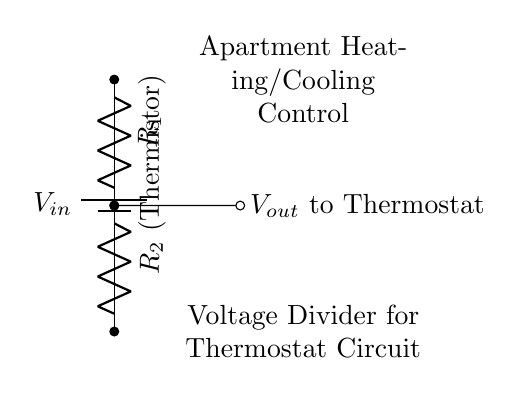What is the power supply voltage in this circuit? The circuit diagram shows a component labeled as "V_in," which represents the input voltage supplied to the circuit. However, the exact value is not indicated in this diagram. The user would need to refer to the specifications or additional documentation for the precise voltage.
Answer: V_in What components are present in the voltage divider? The circuit consists of a battery (V_in), a resistor labeled R_1, and a thermistor labeled R_2. These components are identified visually; the battery provides the input voltage, while the resistors function to create the voltage division necessary for the thermostat's operation.
Answer: Battery, R_1, R_2 What is the output voltage referred to in the circuit? The output voltage is labeled as "V_out" and is indicated to be the voltage across R_2 (the thermistor). This voltage is critical for the thermostat to sense temperature changes and regulate heating or cooling accordingly.
Answer: V_out Which component acts as a sensor in this circuit? The thermistor (R_2) serves as the sensor in the voltage divider circuit. Its resistance changes with temperature, influencing the output voltage (V_out) sent to the thermostat, thus I can adjust the heating and cooling systems based on temperature variations.
Answer: Thermistor How does the thermistor affect the output voltage? The thermistor's resistance changes with temperature, altering the voltage drop across it and thus affecting V_out. If the temperature increases, the resistance of the thermistor typically decreases, raising V_out. Conversely, if the temperature decreases, the resistance rises, causing V_out to drop. This relationship enables the thermostat to control the heating and cooling operations effectively.
Answer: Changes V_out What is the purpose of the voltage divider in this circuit? The voltage divider adjusts the input voltage to a lower output voltage suitable for the thermostat, which allows for proper functioning and control of apartment heating and cooling systems. It makes the output voltage dependent on the temperature sensed by the thermistor, creating a feedback mechanism for temperature regulation.
Answer: Control voltage for thermostat 